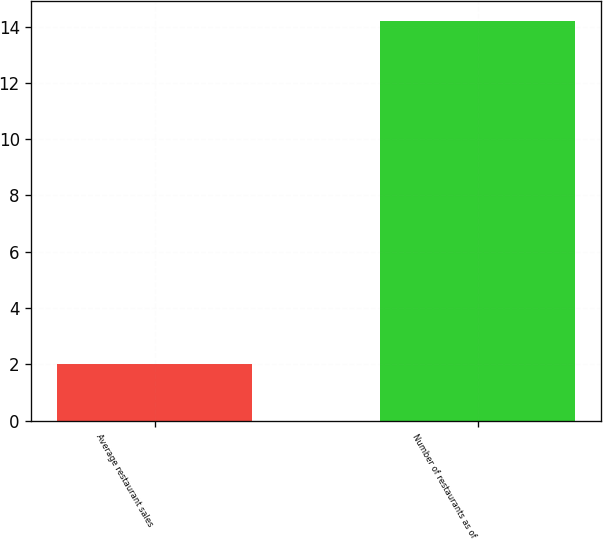Convert chart to OTSL. <chart><loc_0><loc_0><loc_500><loc_500><bar_chart><fcel>Average restaurant sales<fcel>Number of restaurants as of<nl><fcel>2<fcel>14.2<nl></chart> 